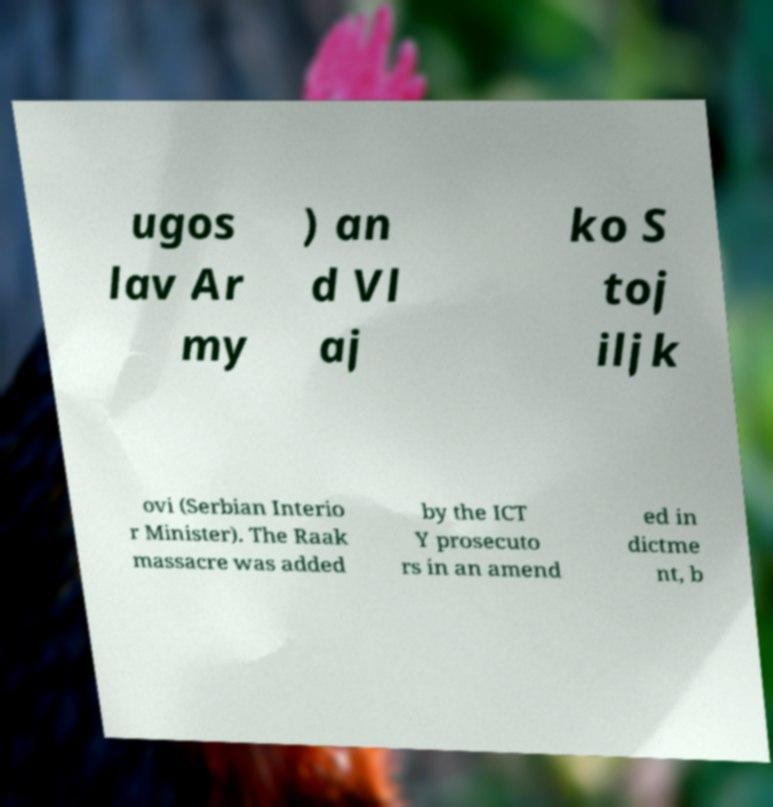What messages or text are displayed in this image? I need them in a readable, typed format. ugos lav Ar my ) an d Vl aj ko S toj iljk ovi (Serbian Interio r Minister). The Raak massacre was added by the ICT Y prosecuto rs in an amend ed in dictme nt, b 